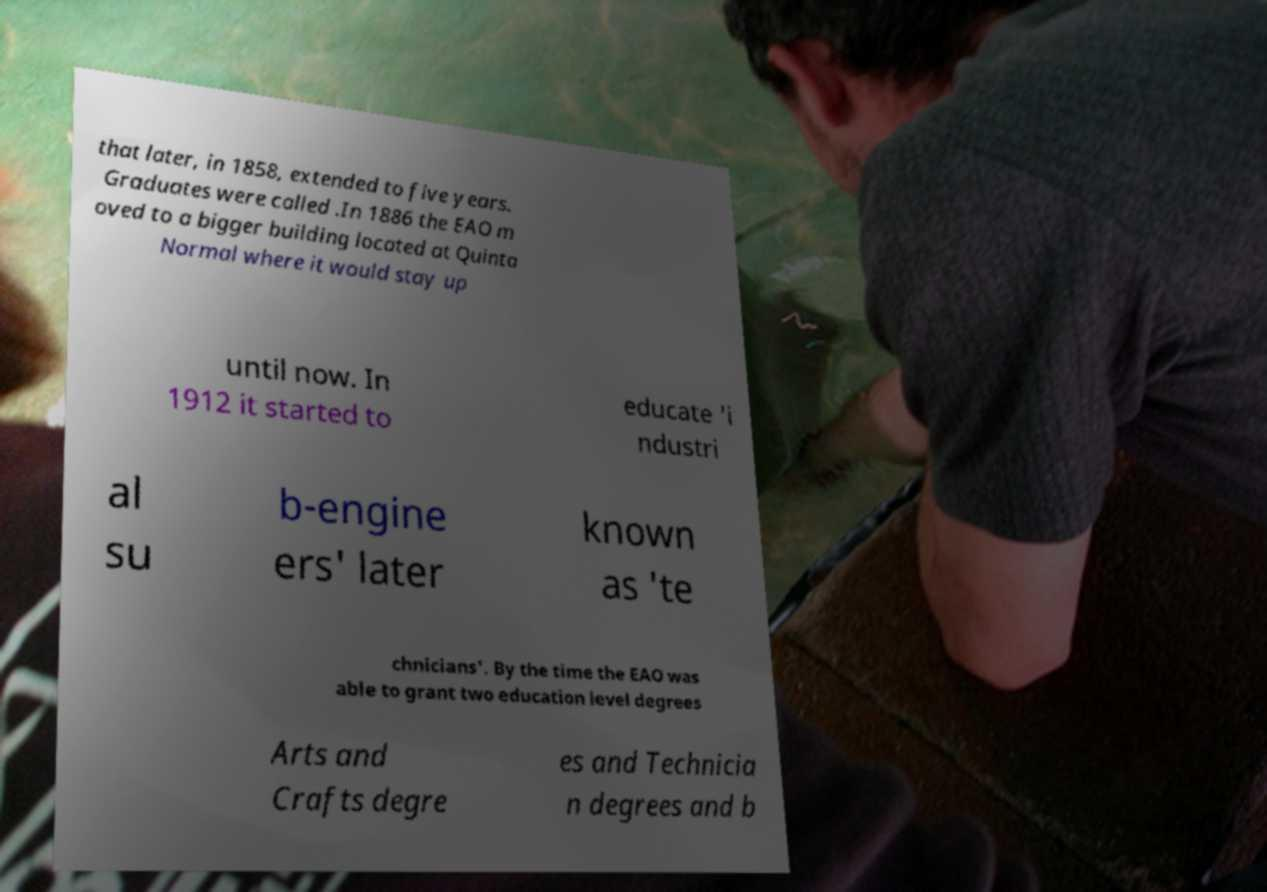Could you extract and type out the text from this image? that later, in 1858, extended to five years. Graduates were called .In 1886 the EAO m oved to a bigger building located at Quinta Normal where it would stay up until now. In 1912 it started to educate 'i ndustri al su b-engine ers' later known as 'te chnicians'. By the time the EAO was able to grant two education level degrees Arts and Crafts degre es and Technicia n degrees and b 